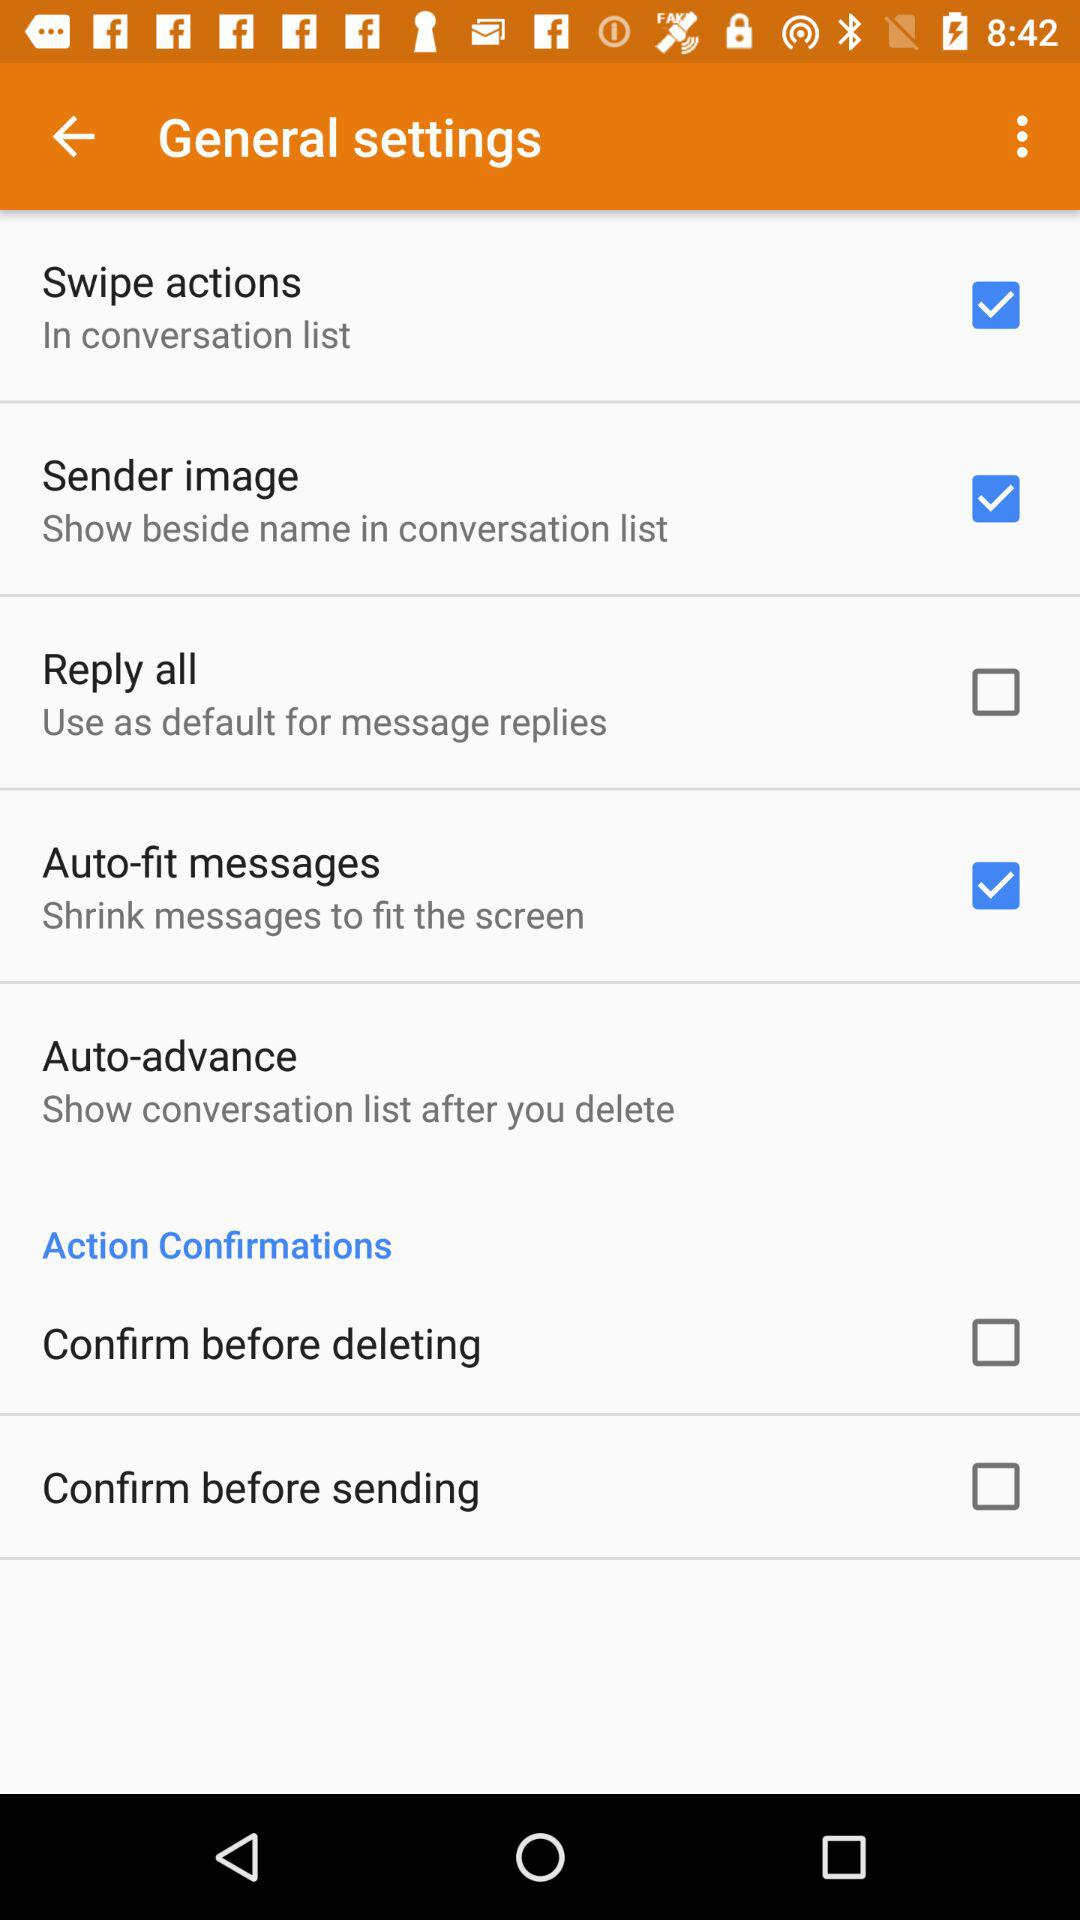How many checkboxes are in the Action Confirmations section?
Answer the question using a single word or phrase. 2 